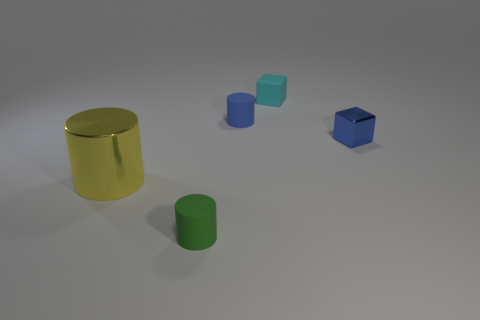What number of small blue things have the same material as the small blue block? There are two small blue objects in the image that appear to have the same material as the small blue block, so the correct number is 2. 